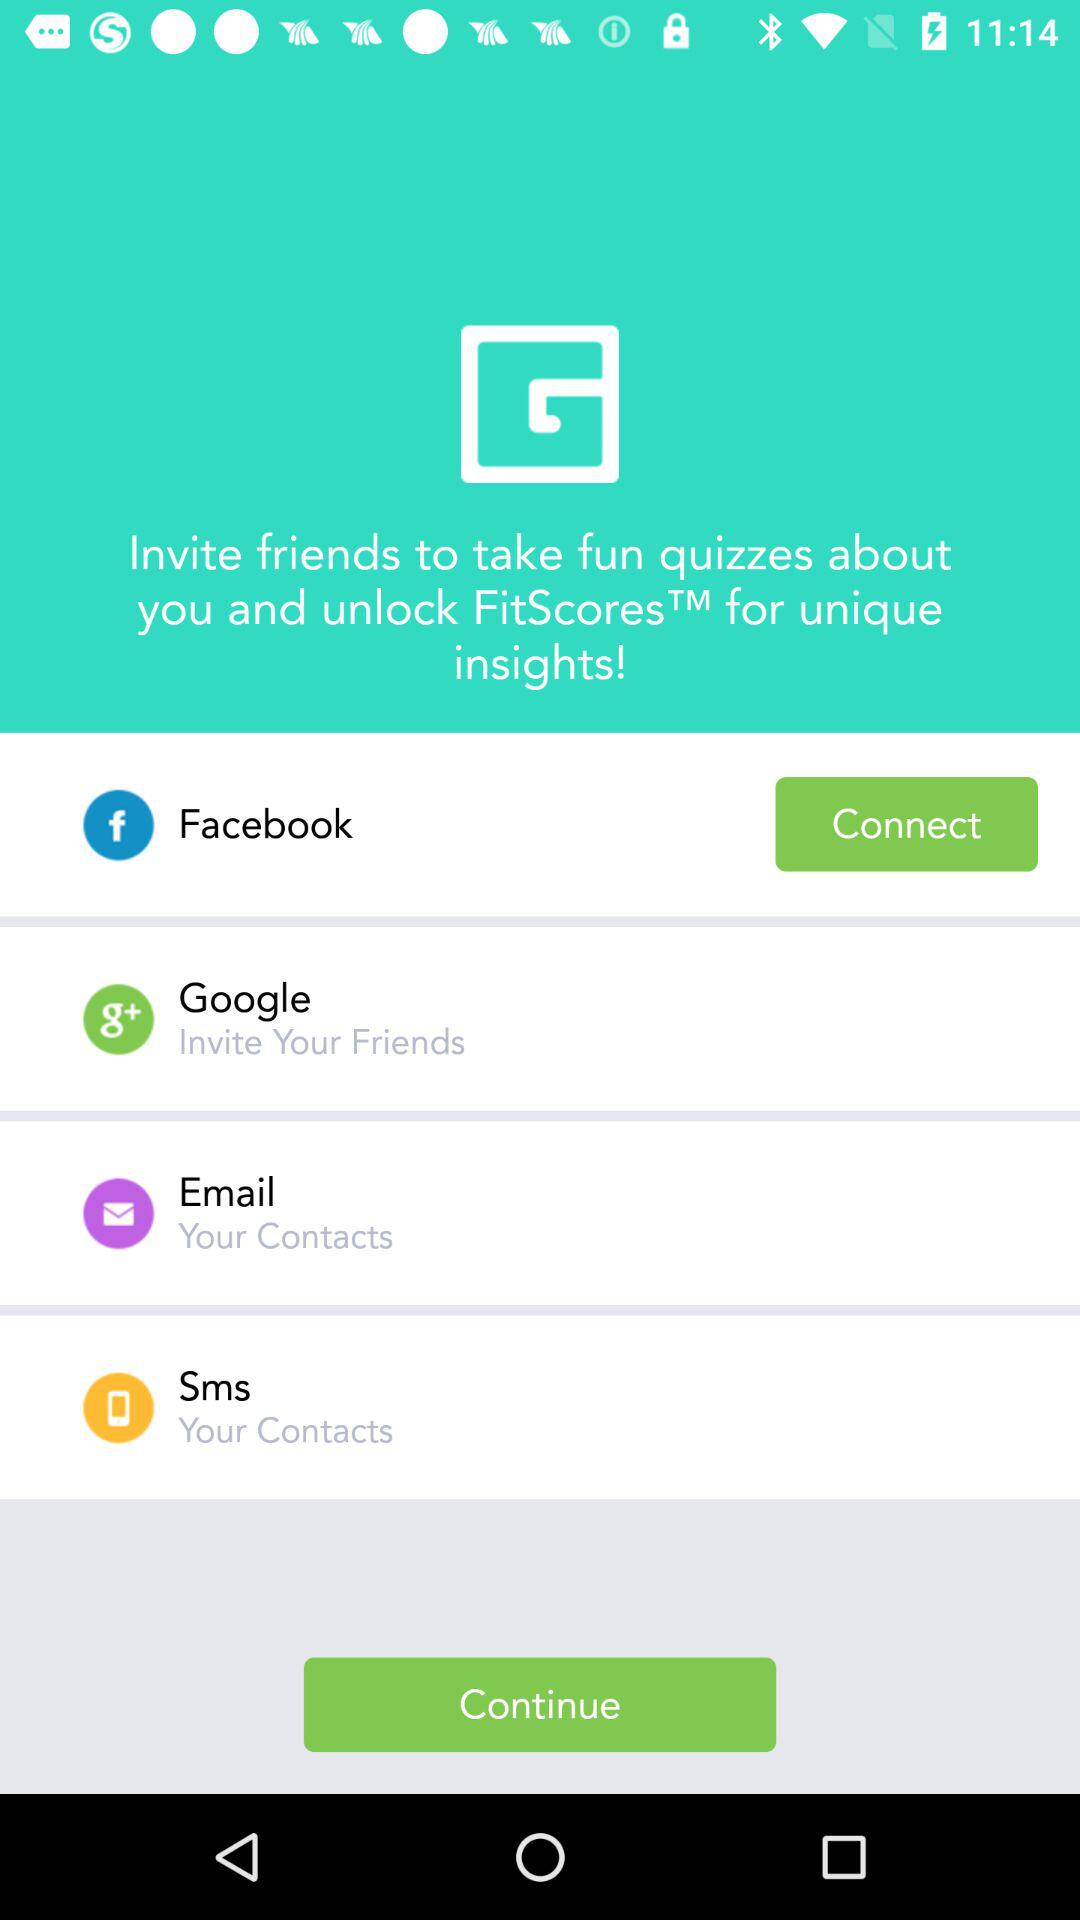How many friends can we invite to take fun quizzes?
When the provided information is insufficient, respond with <no answer>. <no answer> 